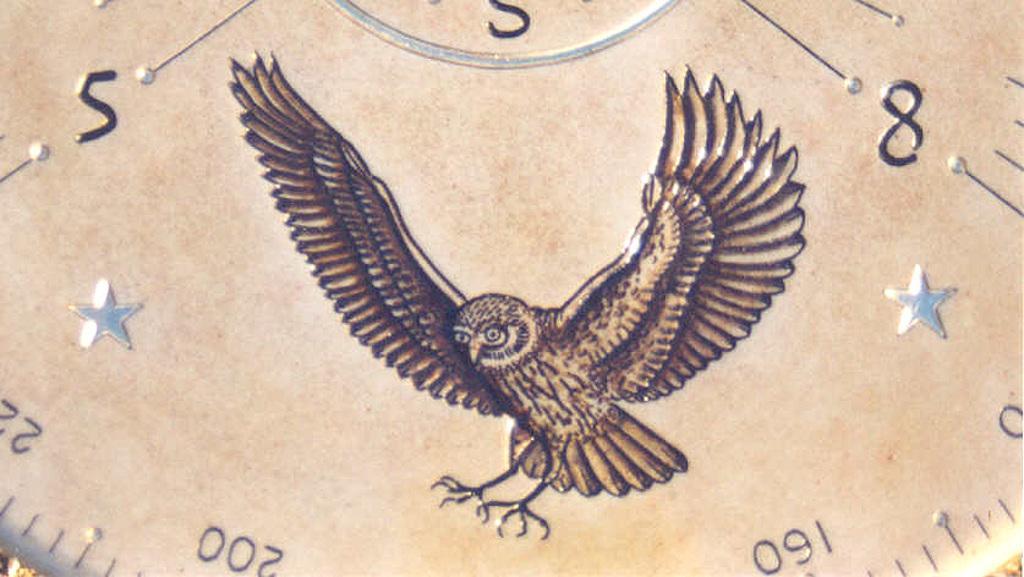How would you summarize this image in a sentence or two? In this image we can see a drawing of a bird. In the background ,we can see group of numbers. 